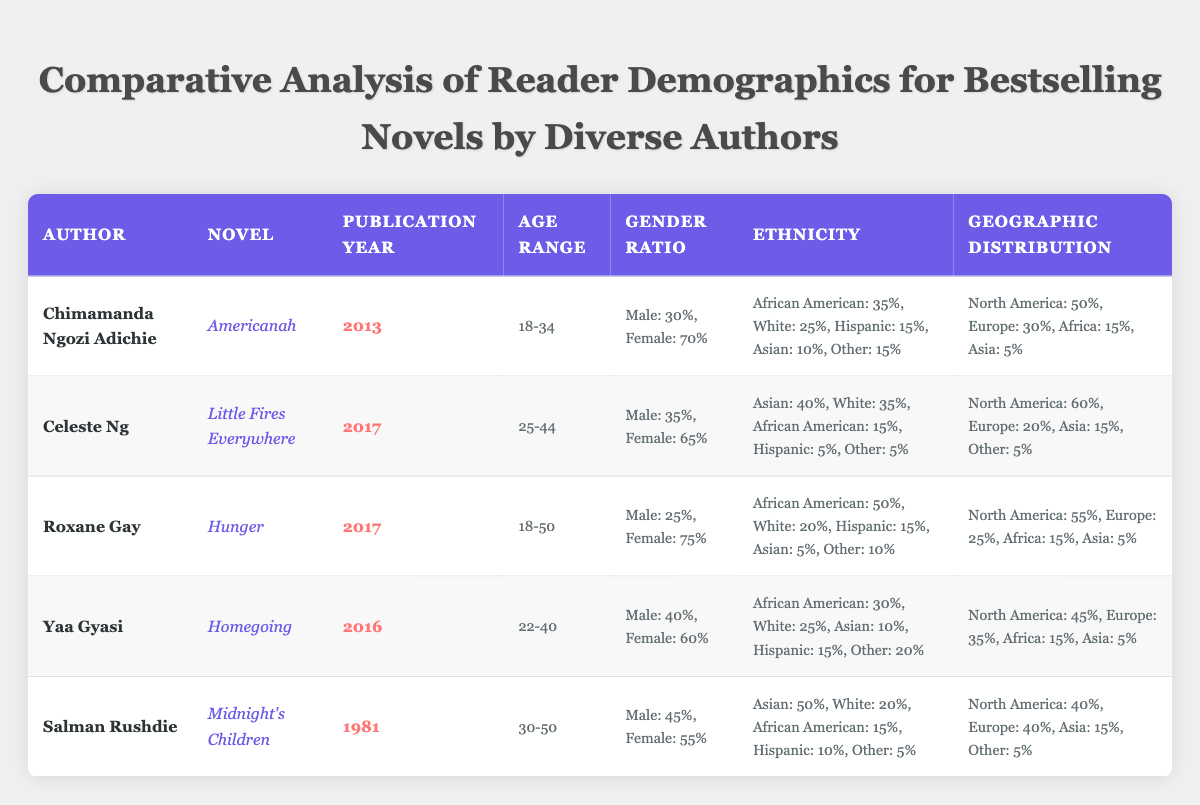What is the publication year of "Homegoing"? The table lists "Homegoing" by Yaa Gyasi, where the publication year is given in the respective column. By scanning the row for Yaa Gyasi, the year provided is 2016.
Answer: 2016 Which novel has the highest percentage of African American readers? By reviewing the ethnicity percentages in each row, "Hunger" by Roxane Gay has the highest percentage of African American readers at 50%.
Answer: Hunger What is the gender ratio for "Little Fires Everywhere"? In the row for "Little Fires Everywhere", the gender ratio shows 35% male and 65% female.
Answer: Male: 35%, Female: 65% How many novels were published after 2015? The publication years listed are: 2013, 2017, 2017, 2016, and 1981. Reading through this data, "Little Fires Everywhere" and "Hunger" were published in 2017, and "Homegoing" was published in 2016, which makes a total of 3 novels published after 2015.
Answer: 3 Is the geographic distribution of "Americanah" more focused on North America or Europe? The geographic distribution for "Americanah" lists 50% in North America and 30% in Europe. Since 50% is greater than 30%, it shows that the readership is more focused on North America.
Answer: Yes What is the average percentage of female readers across all listed novels? The female percentages are: 70% (Americanah), 65% (Little Fires Everywhere), 75% (Hunger), 60% (Homegoing), and 55% (Midnight's Children). The sum of these values is 70 + 65 + 75 + 60 + 55 = 325, and there are 5 novels. The average is calculated as 325/5 = 65%.
Answer: 65% Which author has the oldest published novel in the table? The table includes publication years: 2013, 2017, 2017, 2016, and 1981. Since 1981 is the oldest, it corresponds to "Midnight's Children" by Salman Rushdie.
Answer: Salman Rushdie Are there any novels with a gender ratio favoring male readers? The gender ratios listed show "Americanah" (30% male), "Little Fires Everywhere" (35% male), "Hunger" (25% male), "Homegoing" (40% male), and "Midnight's Children" (45% male). Since all percentages of males are below 50%, there are no novels with a male-favoring gender ratio.
Answer: No What is the combined percentage of readers from Europe for all novels? The European percentages are: 30% (Americanah), 20% (Little Fires Everywhere), 25% (Hunger), 35% (Homegoing), and 40% (Midnight's Children). Adding these gives 30 + 20 + 25 + 35 + 40 = 150%. This total indicates the overall reach of readership from Europe for these novels.
Answer: 150% 